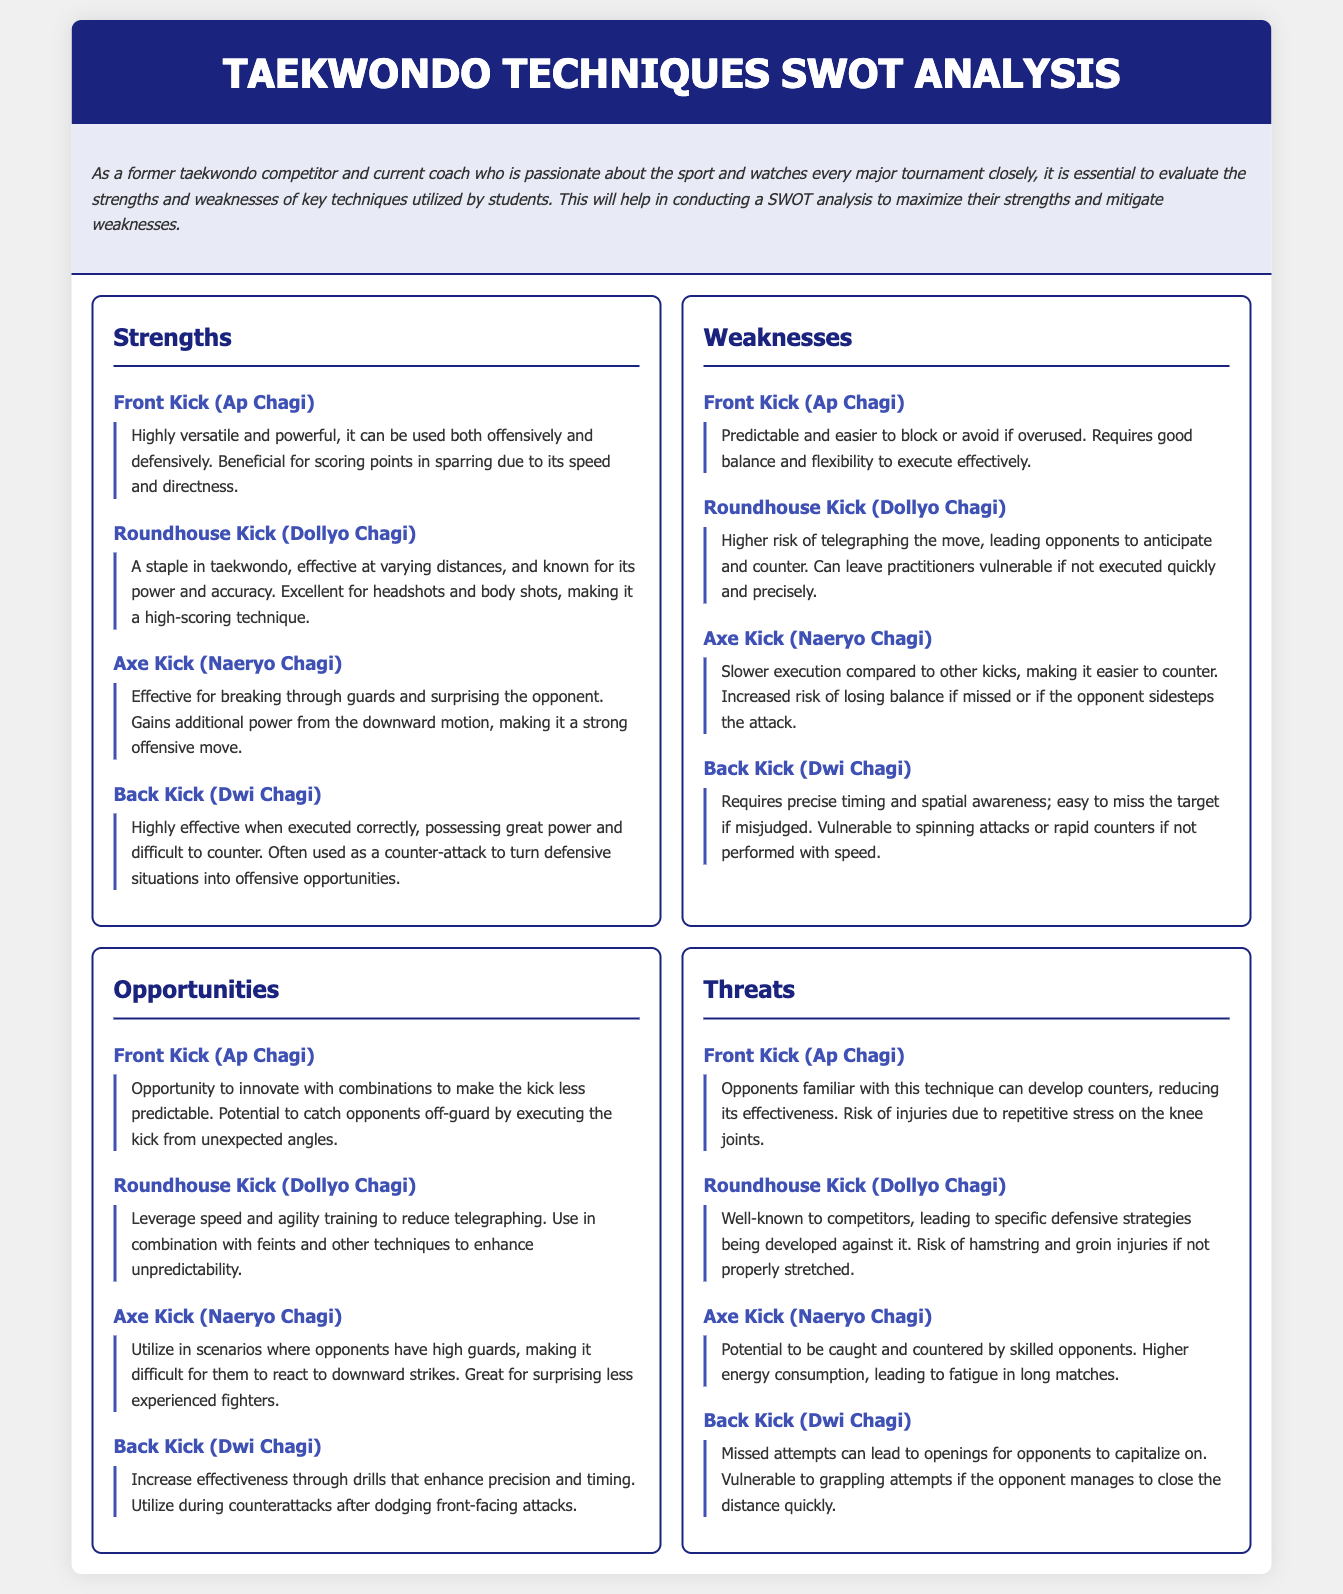what is the main purpose of the document? The document analyzes the strengths and weaknesses of key taekwondo techniques utilized by students, which helps maximize strengths and mitigate weaknesses.
Answer: SWOT analysis of taekwondo techniques how many techniques are listed under strengths? There are four techniques mentioned in the strengths section of the analysis.
Answer: 4 what technique is known for its power and accuracy in varying distances? The Roundhouse Kick (Dollyo Chagi) is known for its power and accuracy in varying distances.
Answer: Roundhouse Kick (Dollyo Chagi) what is a weakness of the Front Kick (Ap Chagi)? A weakness of the Front Kick is that it is predictable and easier to block or avoid if overused.
Answer: Predictable which technique is effective for breaking through guards? The Axe Kick (Naeryo Chagi) is effective for breaking through guards.
Answer: Axe Kick (Naeryo Chagi) describe an opportunity for the Roundhouse Kick. An opportunity for the Roundhouse Kick is leveraging speed and agility training to reduce telegraphing.
Answer: Leverage speed and agility training name a threat associated with the Back Kick (Dwi Chagi). A threat associated with the Back Kick is that missed attempts can lead to openings for opponents to capitalize on.
Answer: Missed attempts which technique is slower in execution compared to other kicks? The Axe Kick (Naeryo Chagi) is slower in execution compared to other kicks.
Answer: Axe Kick (Naeryo Chagi) what is a benefit of using the Front Kick (Ap Chagi) in sparring? The Front Kick is beneficial for scoring points in sparring due to its speed and directness.
Answer: Speed and directness 